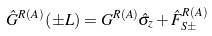<formula> <loc_0><loc_0><loc_500><loc_500>\hat { G } ^ { R ( A ) } \left ( \pm L \right ) = G ^ { R ( A ) } \hat { \sigma } _ { z } + \hat { F } _ { S \pm } ^ { R ( A ) }</formula> 